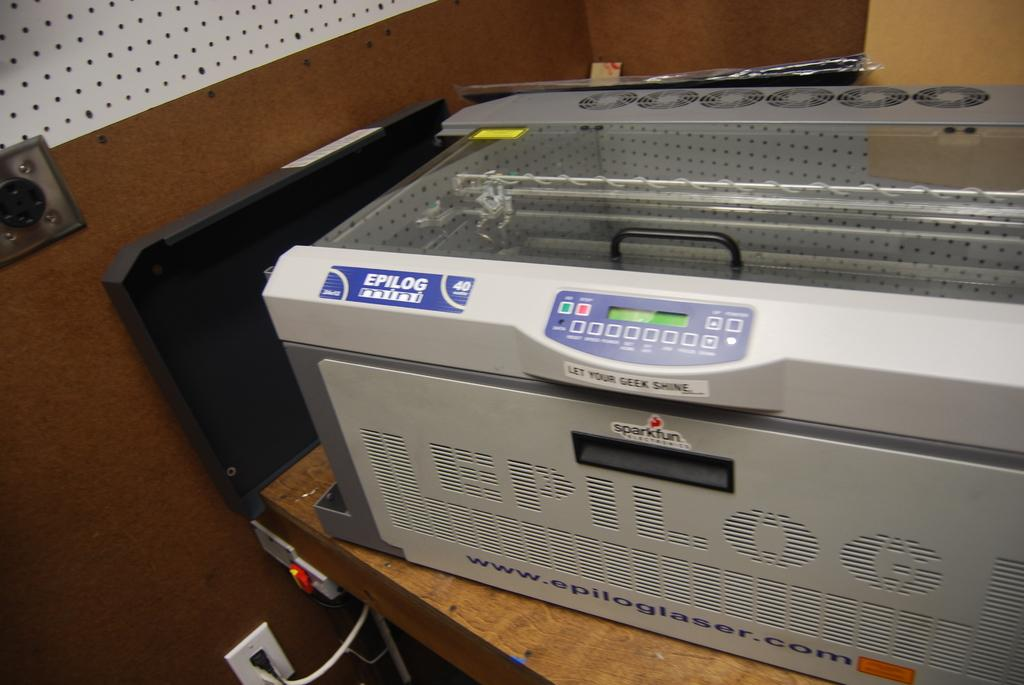<image>
Provide a brief description of the given image. An EPILOG printer sits on top of a wooden table 